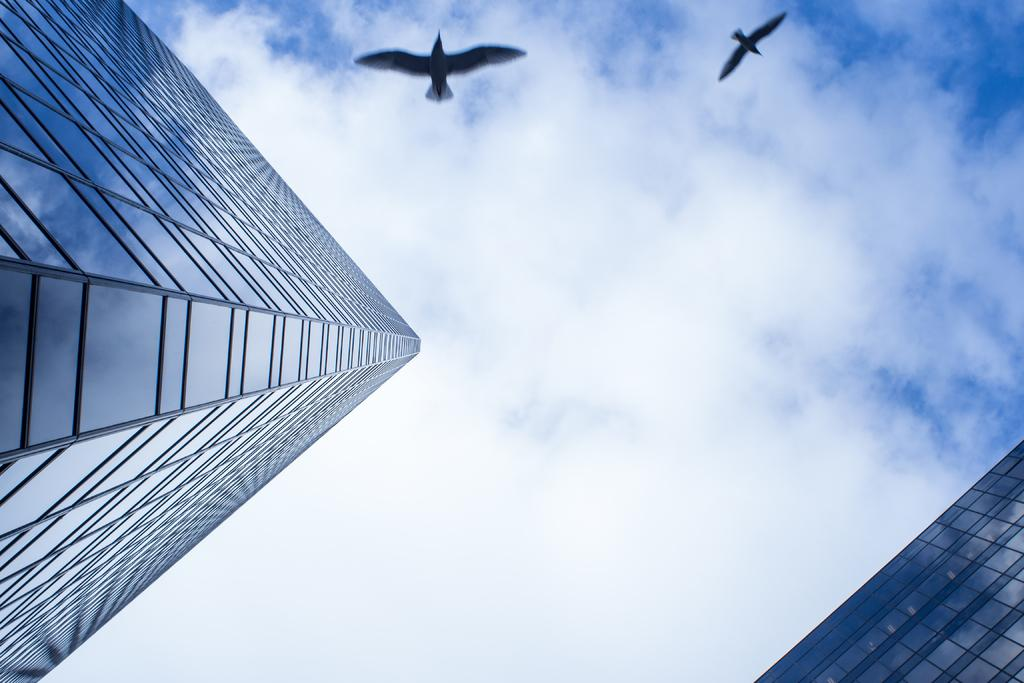How many buildings can be seen in the image? There are two buildings in the image. What else is visible in the sky besides the buildings? Birds are flying in the sky. What is the condition of the sky in the image? The sky appears cloudy. What type of pan is being used to cook the bread in the image? There is no pan or bread present in the image; it only features two buildings and birds flying in the sky. 